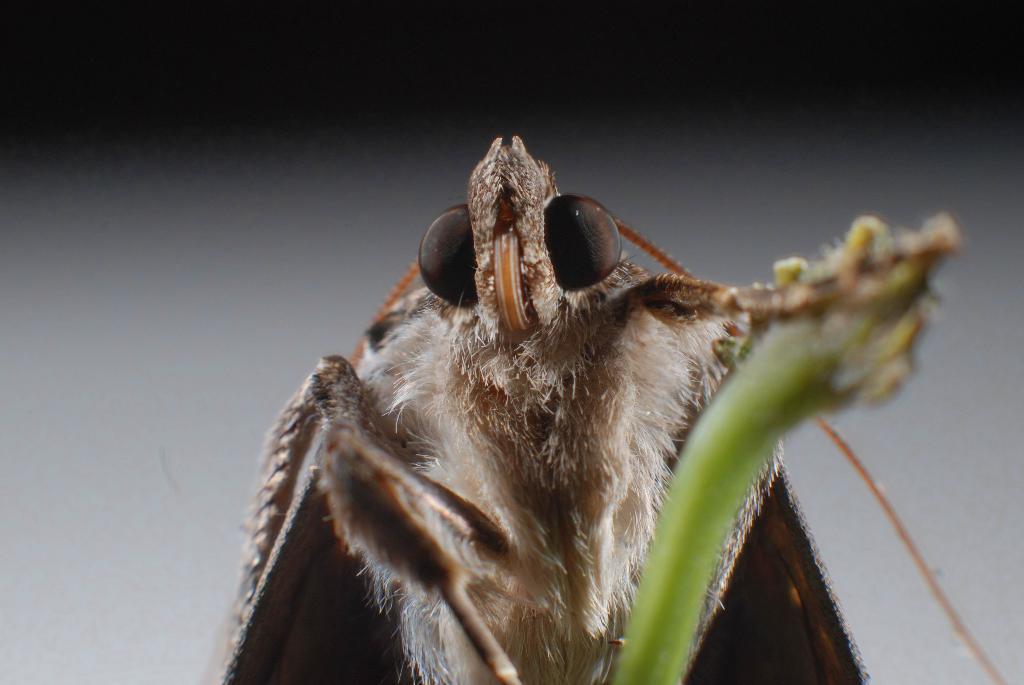Could you give a brief overview of what you see in this image? In this image we can see an insect. 